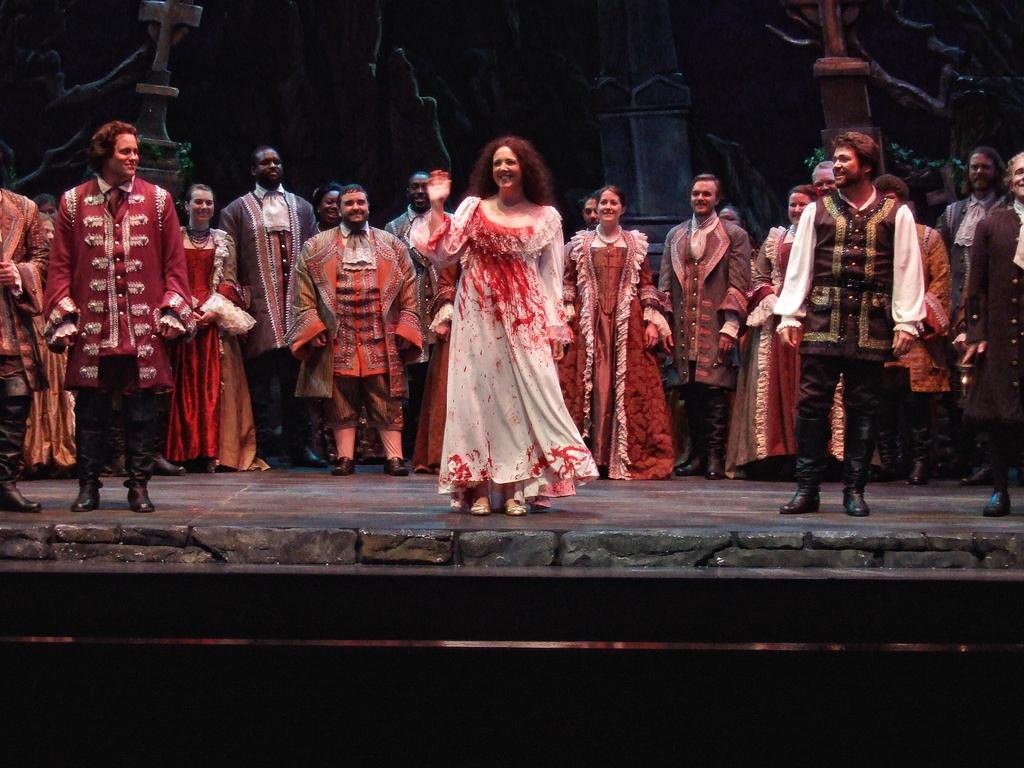What can be seen in the foreground of the image? There are people standing in the front of the image. What is located in the background of the image? There is a pillar in the background of the image, as well as other objects. How many people are sleeping in the image? There is no indication of anyone sleeping in the image; people are standing in the front. 